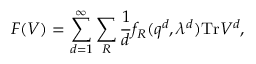Convert formula to latex. <formula><loc_0><loc_0><loc_500><loc_500>F ( V ) = \sum _ { d = 1 } ^ { \infty } \sum _ { R } { \frac { 1 } { d } } f _ { R } ( q ^ { d } , \lambda ^ { d } ) T r V ^ { d } ,</formula> 